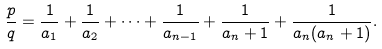Convert formula to latex. <formula><loc_0><loc_0><loc_500><loc_500>\frac { p } { q } = \frac { 1 } { a _ { 1 } } + \frac { 1 } { a _ { 2 } } + \cdots + \frac { 1 } { a _ { n - 1 } } + \frac { 1 } { a _ { n } + 1 } + \frac { 1 } { a _ { n } ( a _ { n } + 1 ) } .</formula> 